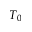Convert formula to latex. <formula><loc_0><loc_0><loc_500><loc_500>T _ { 0 }</formula> 